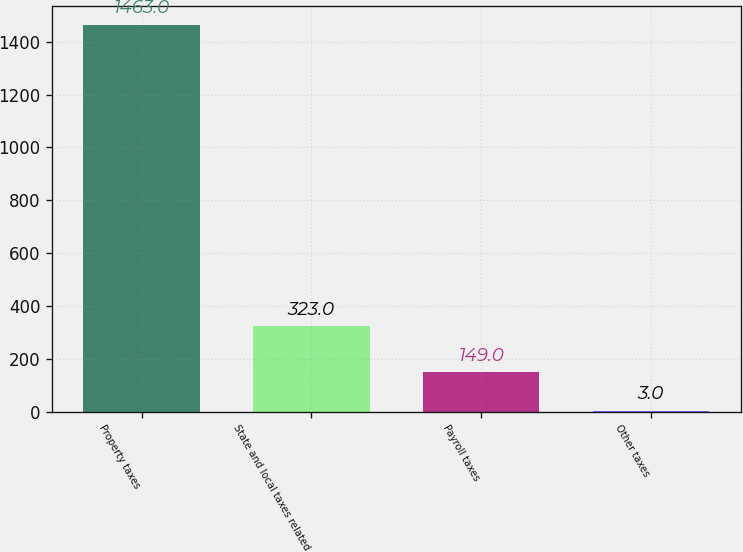<chart> <loc_0><loc_0><loc_500><loc_500><bar_chart><fcel>Property taxes<fcel>State and local taxes related<fcel>Payroll taxes<fcel>Other taxes<nl><fcel>1463<fcel>323<fcel>149<fcel>3<nl></chart> 